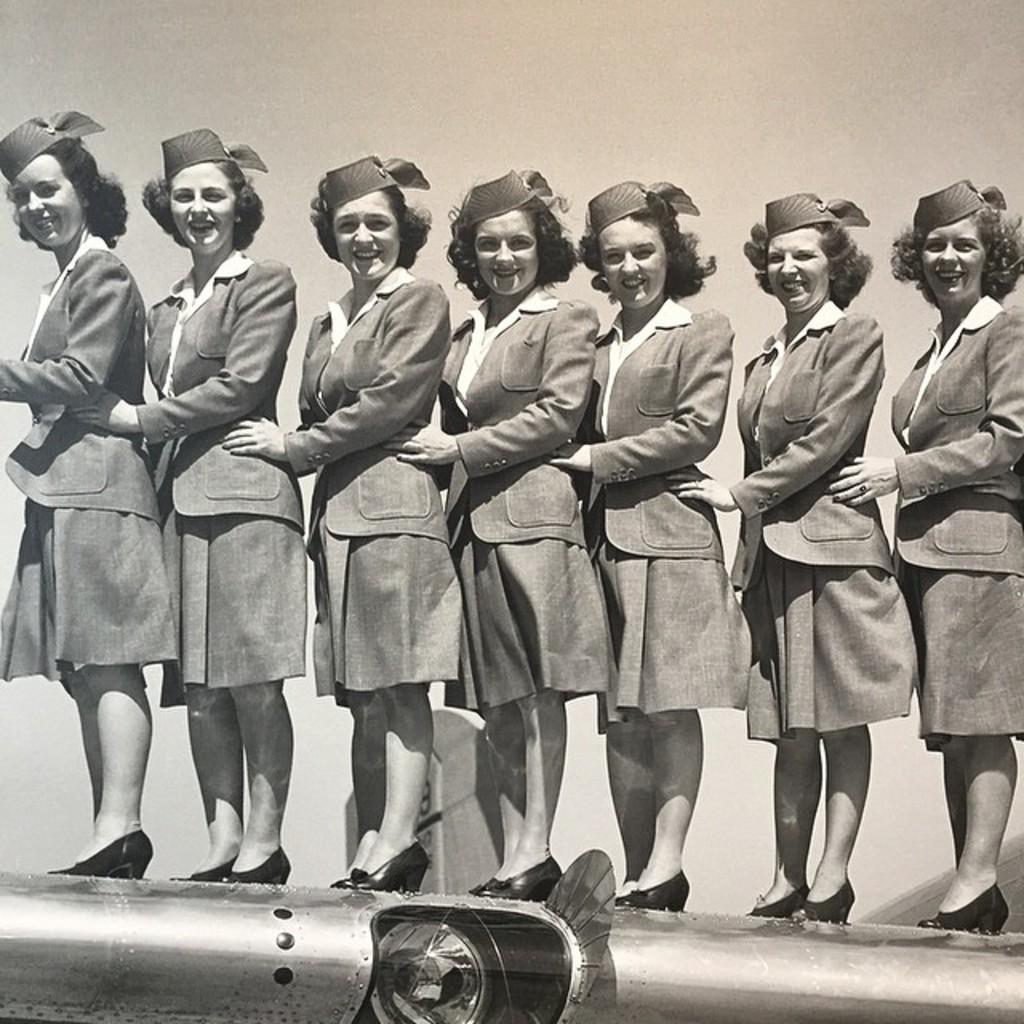What is the main subject of the image? The main subject of the image is a group of people. What are the people wearing in the image? The people are wearing uniforms in the image. Where are the people standing in the image? The people are standing on a vehicle in the image. Can you see the grandmother on the island in the image? There is no island or grandmother present in the image. 